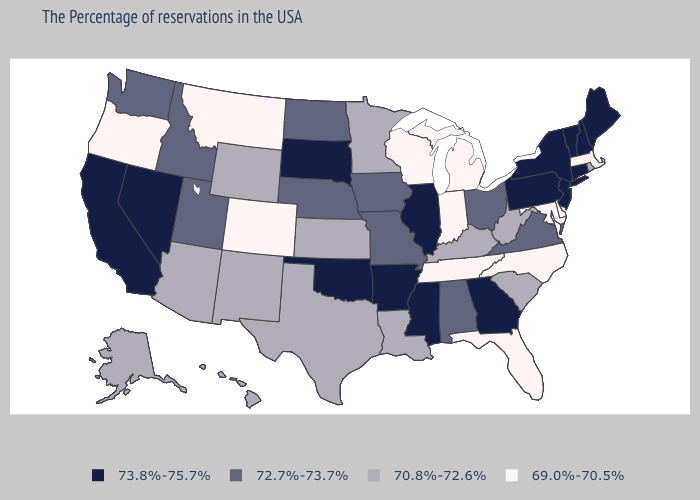Does Michigan have the lowest value in the USA?
Be succinct. Yes. Which states have the highest value in the USA?
Short answer required. Maine, New Hampshire, Vermont, Connecticut, New York, New Jersey, Pennsylvania, Georgia, Illinois, Mississippi, Arkansas, Oklahoma, South Dakota, Nevada, California. Name the states that have a value in the range 73.8%-75.7%?
Concise answer only. Maine, New Hampshire, Vermont, Connecticut, New York, New Jersey, Pennsylvania, Georgia, Illinois, Mississippi, Arkansas, Oklahoma, South Dakota, Nevada, California. Name the states that have a value in the range 73.8%-75.7%?
Give a very brief answer. Maine, New Hampshire, Vermont, Connecticut, New York, New Jersey, Pennsylvania, Georgia, Illinois, Mississippi, Arkansas, Oklahoma, South Dakota, Nevada, California. Name the states that have a value in the range 73.8%-75.7%?
Keep it brief. Maine, New Hampshire, Vermont, Connecticut, New York, New Jersey, Pennsylvania, Georgia, Illinois, Mississippi, Arkansas, Oklahoma, South Dakota, Nevada, California. What is the lowest value in the Northeast?
Short answer required. 69.0%-70.5%. What is the highest value in states that border Alabama?
Write a very short answer. 73.8%-75.7%. What is the highest value in the USA?
Quick response, please. 73.8%-75.7%. Among the states that border Arizona , does California have the lowest value?
Quick response, please. No. Among the states that border South Carolina , does Georgia have the lowest value?
Concise answer only. No. Name the states that have a value in the range 73.8%-75.7%?
Quick response, please. Maine, New Hampshire, Vermont, Connecticut, New York, New Jersey, Pennsylvania, Georgia, Illinois, Mississippi, Arkansas, Oklahoma, South Dakota, Nevada, California. Name the states that have a value in the range 69.0%-70.5%?
Answer briefly. Massachusetts, Delaware, Maryland, North Carolina, Florida, Michigan, Indiana, Tennessee, Wisconsin, Colorado, Montana, Oregon. What is the value of Delaware?
Answer briefly. 69.0%-70.5%. What is the highest value in the Northeast ?
Keep it brief. 73.8%-75.7%. 